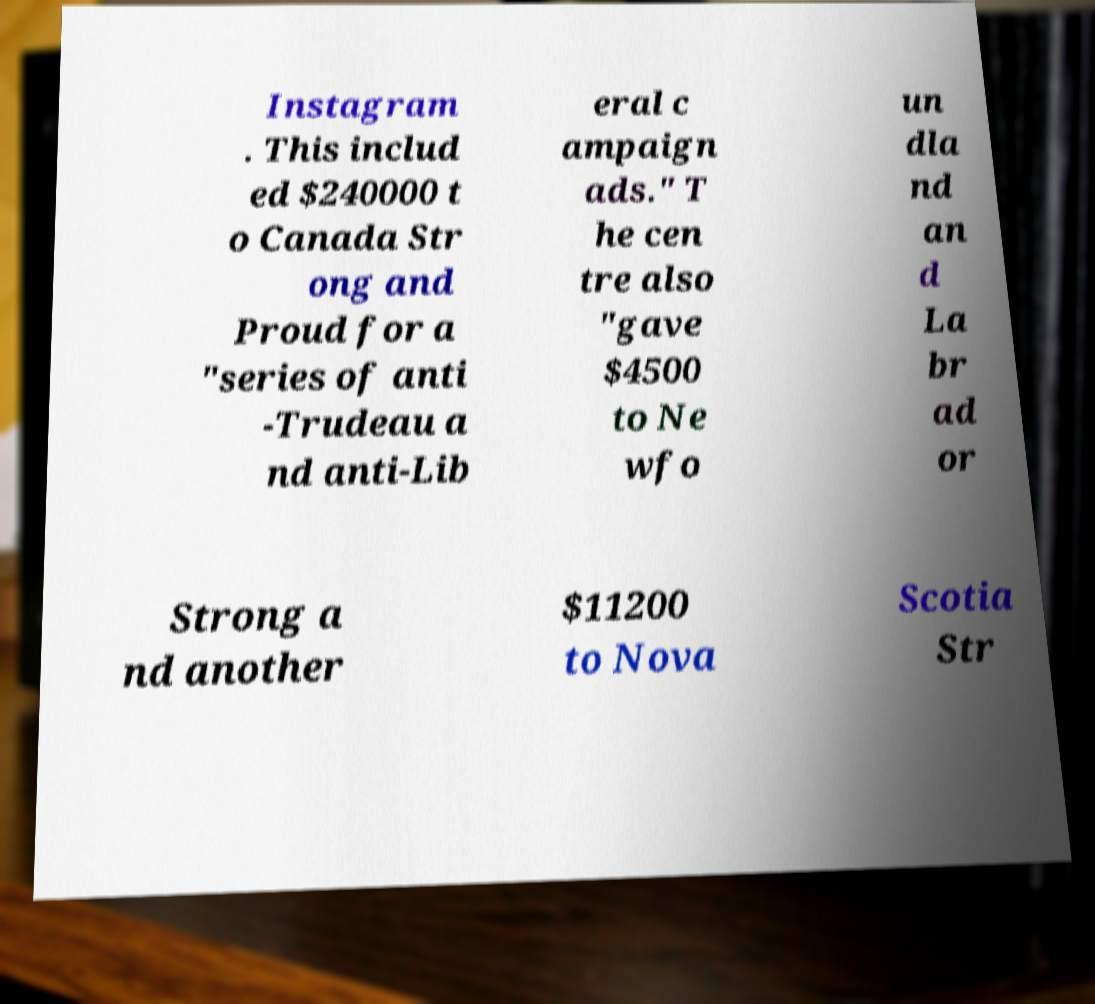Could you extract and type out the text from this image? Instagram . This includ ed $240000 t o Canada Str ong and Proud for a "series of anti -Trudeau a nd anti-Lib eral c ampaign ads." T he cen tre also "gave $4500 to Ne wfo un dla nd an d La br ad or Strong a nd another $11200 to Nova Scotia Str 